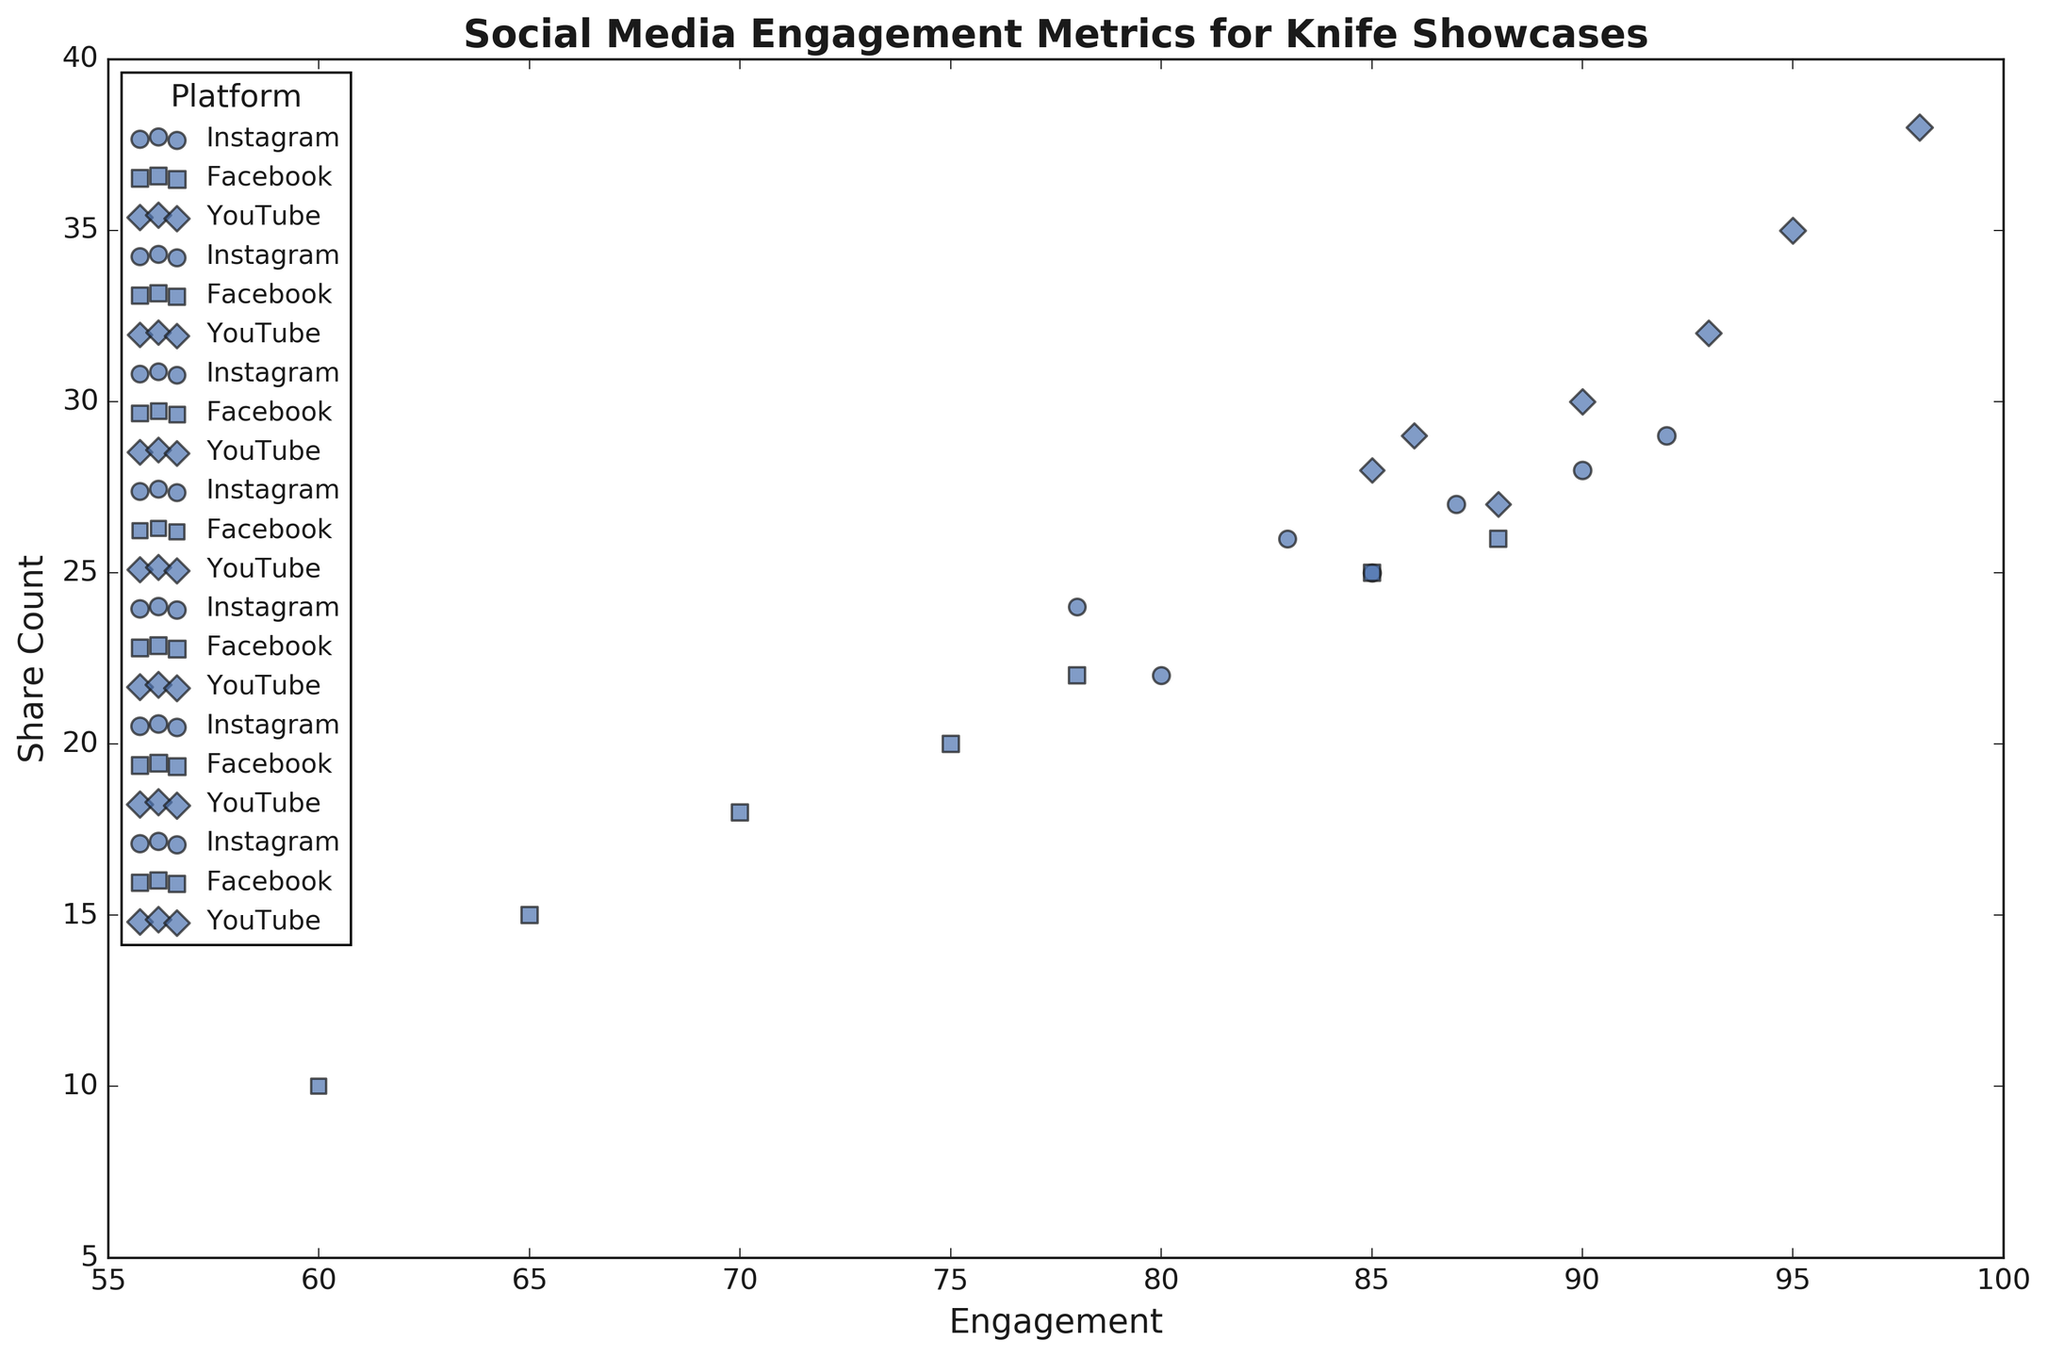Which content type has the highest engagement on YouTube? From the figure, observe the engagement values of different content types plotted for YouTube. Look for the highest engagement value among these points.
Answer: Limited Editions Which platform shows the highest share count for "Vintage Collection"? Locate the data points corresponding to "Vintage Collection" on all three platforms (Instagram, Facebook, YouTube) and compare their share counts visually.
Answer: YouTube For "Custom Knives" content, which platform has the lowest engagement? Identify the data points for "Custom Knives" content on all three platforms. Then check and compare their engagement values.
Answer: Facebook Which platform shows the highest engagement for "Unboxing" content? Locate the "Unboxing" content type across all three platforms on the plot and compare their engagement values.
Answer: YouTube What is the average engagement for all content types on Instagram? Sum all engagement values for Instagram content types (85 + 80 + 78 + 83 + 90 + 92 + 87) = 595, and then divide by the number of content types (7).
Answer: 85 Which content type on Facebook has both engagement and share count lower than 70 and 20 respectively? To answer, locate points representing Facebook on the graph. Identify them with engagement less than 70 and shares less than 20. Check for both conditions simultaneously.
Answer: Comparison Between Instagram and YouTube, which platform has a higher average share count for "Review" content? Calculate the average share count for "Review" content on both Instagram (25), and YouTube (30) and compare the two.
Answer: YouTube Which platform has the largest bubble for "Limited Editions" content, indicating the highest view count? Look at the bubbles corresponding to "Limited Editions" for each platform and identify the one with the largest size.
Answer: YouTube How do the engagements for "Tutorial" content on Instagram and Facebook compare? Check and compare the engagement values of "Tutorial" content on Instagram (78) and Facebook (65) visually from the plot.
Answer: Instagram has higher engagement For "Comparison" content type, which platform has the highest share count? Identify the data points for "Comparison" content type for each platform and visually compare their share counts.
Answer: Instagram 